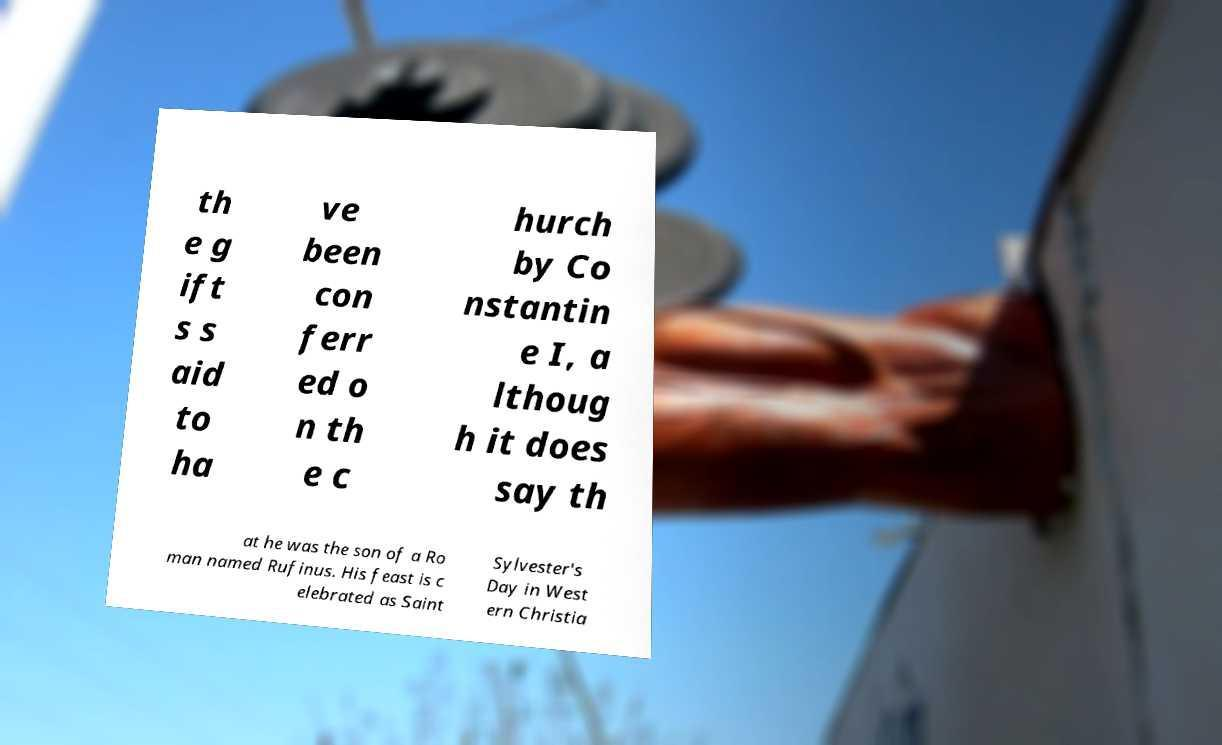Can you read and provide the text displayed in the image?This photo seems to have some interesting text. Can you extract and type it out for me? th e g ift s s aid to ha ve been con ferr ed o n th e c hurch by Co nstantin e I, a lthoug h it does say th at he was the son of a Ro man named Rufinus. His feast is c elebrated as Saint Sylvester's Day in West ern Christia 